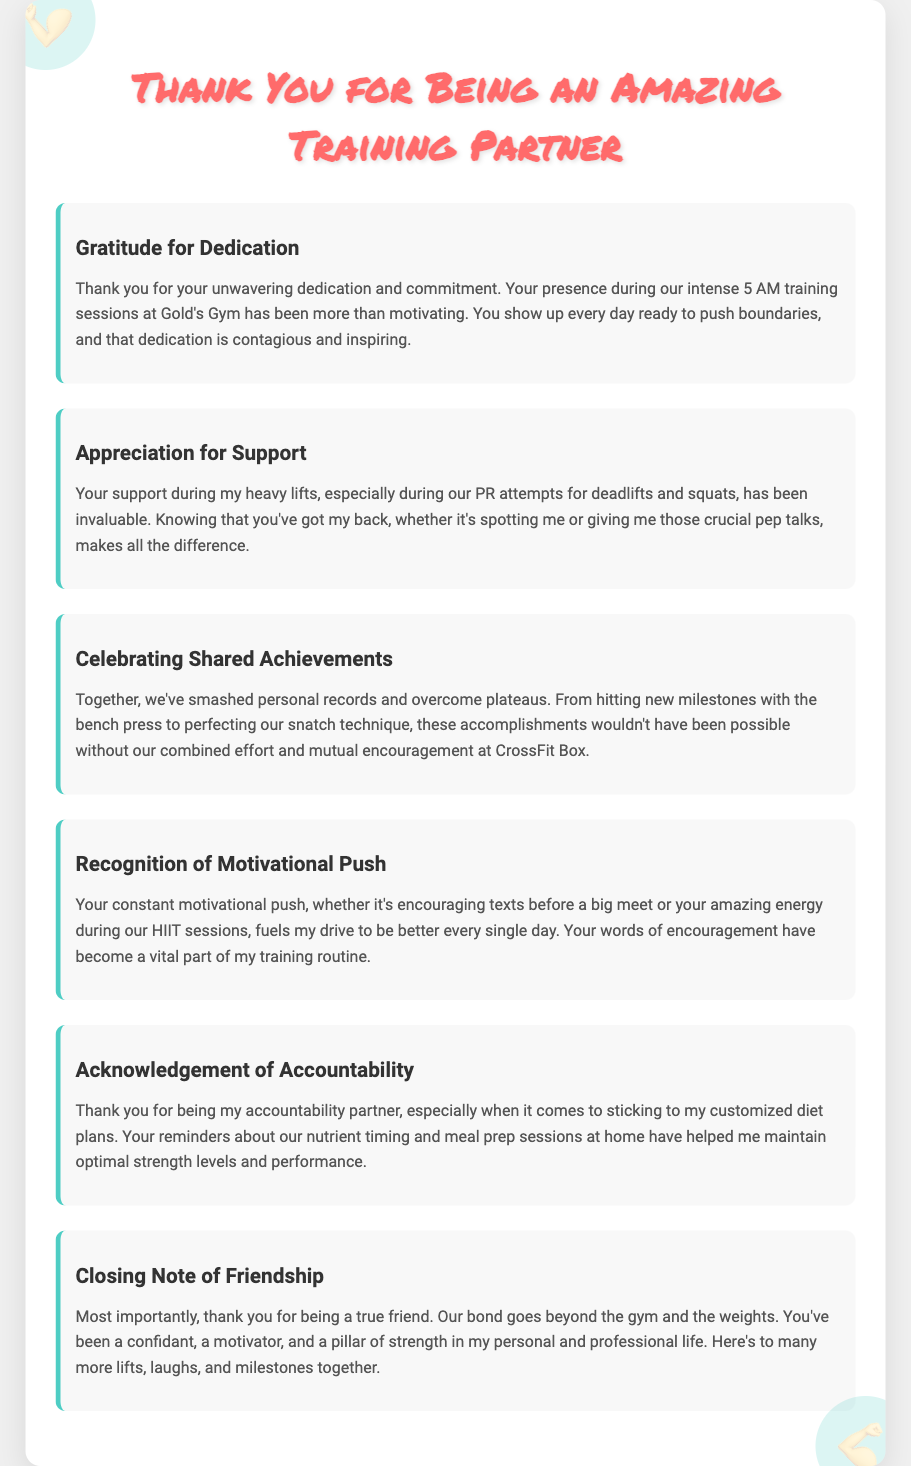What is the title of the card? The title of the card is prominently displayed at the top and expresses gratitude.
Answer: Thank You for Being an Amazing Training Partner How many sections are in the card? The card contains multiple sections, each focusing on a different aspect of appreciation.
Answer: Six What time do the training sessions occur? The card mentions a specific time for training sessions that shows the dedication of the training partner.
Answer: 5 AM What gym is mentioned in the document? The document references a specific gym where the training sessions take place.
Answer: Gold's Gym Which lifting techniques are noted as shared achievements? The document lists specific lifting techniques that highlight their shared accomplishments.
Answer: Bench press and snatch What key concept is emphasized throughout the card? The document illustrates an important theme that connects the training partner's qualities to personal training growth.
Answer: Support What aspect of nutrition is acknowledged? The card refers to the importance of dietary habits and responsibilities in achieving training goals.
Answer: Customized diet plans What type of relationship is highlighted in the card? The document emphasizes a particular type of bond that extends beyond training.
Answer: Friendship 